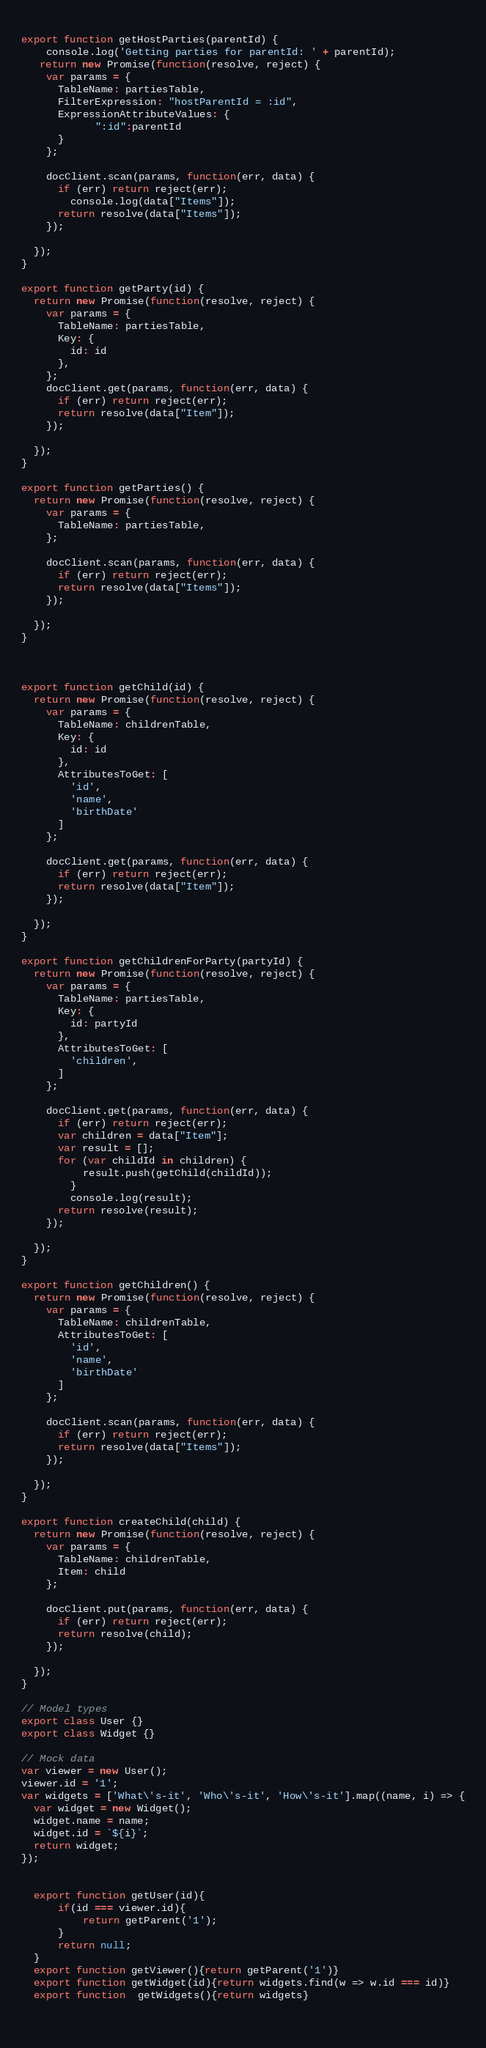<code> <loc_0><loc_0><loc_500><loc_500><_JavaScript_>    
export function getHostParties(parentId) {
    console.log('Getting parties for parentId: ' + parentId);
   return new Promise(function(resolve, reject) {
    var params = {
      TableName: partiesTable,
      FilterExpression: "hostParentId = :id",
      ExpressionAttributeValues: {
            ":id":parentId
      }
    };

    docClient.scan(params, function(err, data) {
      if (err) return reject(err);
        console.log(data["Items"]);
      return resolve(data["Items"]);
    });

  });
}

export function getParty(id) {
  return new Promise(function(resolve, reject) {
    var params = {
      TableName: partiesTable,
      Key: {
        id: id
      },
    };  
    docClient.get(params, function(err, data) {
      if (err) return reject(err);
      return resolve(data["Item"]);
    });
      
  });
}
                     
export function getParties() {
  return new Promise(function(resolve, reject) {
    var params = {
      TableName: partiesTable,
    };

    docClient.scan(params, function(err, data) {
      if (err) return reject(err);
      return resolve(data["Items"]);
    });

  });
}



export function getChild(id) {
  return new Promise(function(resolve, reject) {
    var params = {
      TableName: childrenTable,
      Key: {
        id: id
      },
      AttributesToGet: [
        'id',
        'name',
        'birthDate'  
      ]
    };

    docClient.get(params, function(err, data) {
      if (err) return reject(err);
      return resolve(data["Item"]);
    });

  });
}

export function getChildrenForParty(partyId) {
  return new Promise(function(resolve, reject) {
    var params = {
      TableName: partiesTable,
      Key: {
        id: partyId
      },
      AttributesToGet: [
        'children', 
      ]
    };

    docClient.get(params, function(err, data) {
      if (err) return reject(err);
      var children = data["Item"];
      var result = [];
      for (var childId in children) {
          result.push(getChild(childId));
        }
        console.log(result);
      return resolve(result);
    });

  });
}
    
export function getChildren() {
  return new Promise(function(resolve, reject) {
    var params = {
      TableName: childrenTable,
      AttributesToGet: [
        'id',
        'name',
        'birthDate'  
      ]
    };

    docClient.scan(params, function(err, data) {
      if (err) return reject(err);
      return resolve(data["Items"]);
    });

  });
}

export function createChild(child) {
  return new Promise(function(resolve, reject) {
    var params = {
      TableName: childrenTable,
      Item: child
    };

    docClient.put(params, function(err, data) {
      if (err) return reject(err);
      return resolve(child);
    });

  });
}    

// Model types
export class User {}
export class Widget {}

// Mock data
var viewer = new User();
viewer.id = '1';
var widgets = ['What\'s-it', 'Who\'s-it', 'How\'s-it'].map((name, i) => {
  var widget = new Widget();
  widget.name = name;
  widget.id = `${i}`;
  return widget;
});


  export function getUser(id){
      if(id === viewer.id){
          return getParent('1');
      }
      return null;
  }
  export function getViewer(){return getParent('1')} 
  export function getWidget(id){return widgets.find(w => w.id === id)}
  export function  getWidgets(){return widgets}
  
    
</code> 